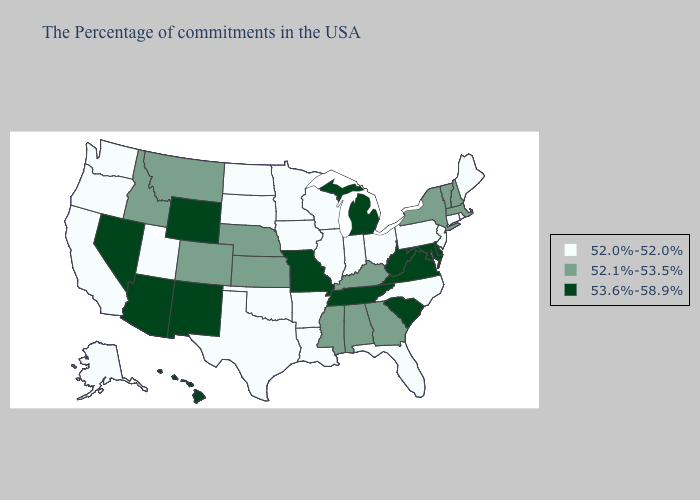Which states have the lowest value in the USA?
Write a very short answer. Maine, Rhode Island, Connecticut, New Jersey, Pennsylvania, North Carolina, Ohio, Florida, Indiana, Wisconsin, Illinois, Louisiana, Arkansas, Minnesota, Iowa, Oklahoma, Texas, South Dakota, North Dakota, Utah, California, Washington, Oregon, Alaska. Name the states that have a value in the range 52.1%-53.5%?
Be succinct. Massachusetts, New Hampshire, Vermont, New York, Georgia, Kentucky, Alabama, Mississippi, Kansas, Nebraska, Colorado, Montana, Idaho. Does Alabama have the same value as Colorado?
Be succinct. Yes. What is the lowest value in states that border Illinois?
Give a very brief answer. 52.0%-52.0%. Does Washington have a higher value than Nevada?
Give a very brief answer. No. What is the lowest value in the Northeast?
Be succinct. 52.0%-52.0%. What is the value of Massachusetts?
Give a very brief answer. 52.1%-53.5%. Name the states that have a value in the range 53.6%-58.9%?
Keep it brief. Delaware, Maryland, Virginia, South Carolina, West Virginia, Michigan, Tennessee, Missouri, Wyoming, New Mexico, Arizona, Nevada, Hawaii. Name the states that have a value in the range 52.1%-53.5%?
Quick response, please. Massachusetts, New Hampshire, Vermont, New York, Georgia, Kentucky, Alabama, Mississippi, Kansas, Nebraska, Colorado, Montana, Idaho. What is the value of South Carolina?
Give a very brief answer. 53.6%-58.9%. Among the states that border North Dakota , which have the highest value?
Answer briefly. Montana. What is the value of Texas?
Concise answer only. 52.0%-52.0%. Does Illinois have the highest value in the USA?
Be succinct. No. Among the states that border Pennsylvania , does Ohio have the highest value?
Short answer required. No. Does North Carolina have the highest value in the South?
Keep it brief. No. 